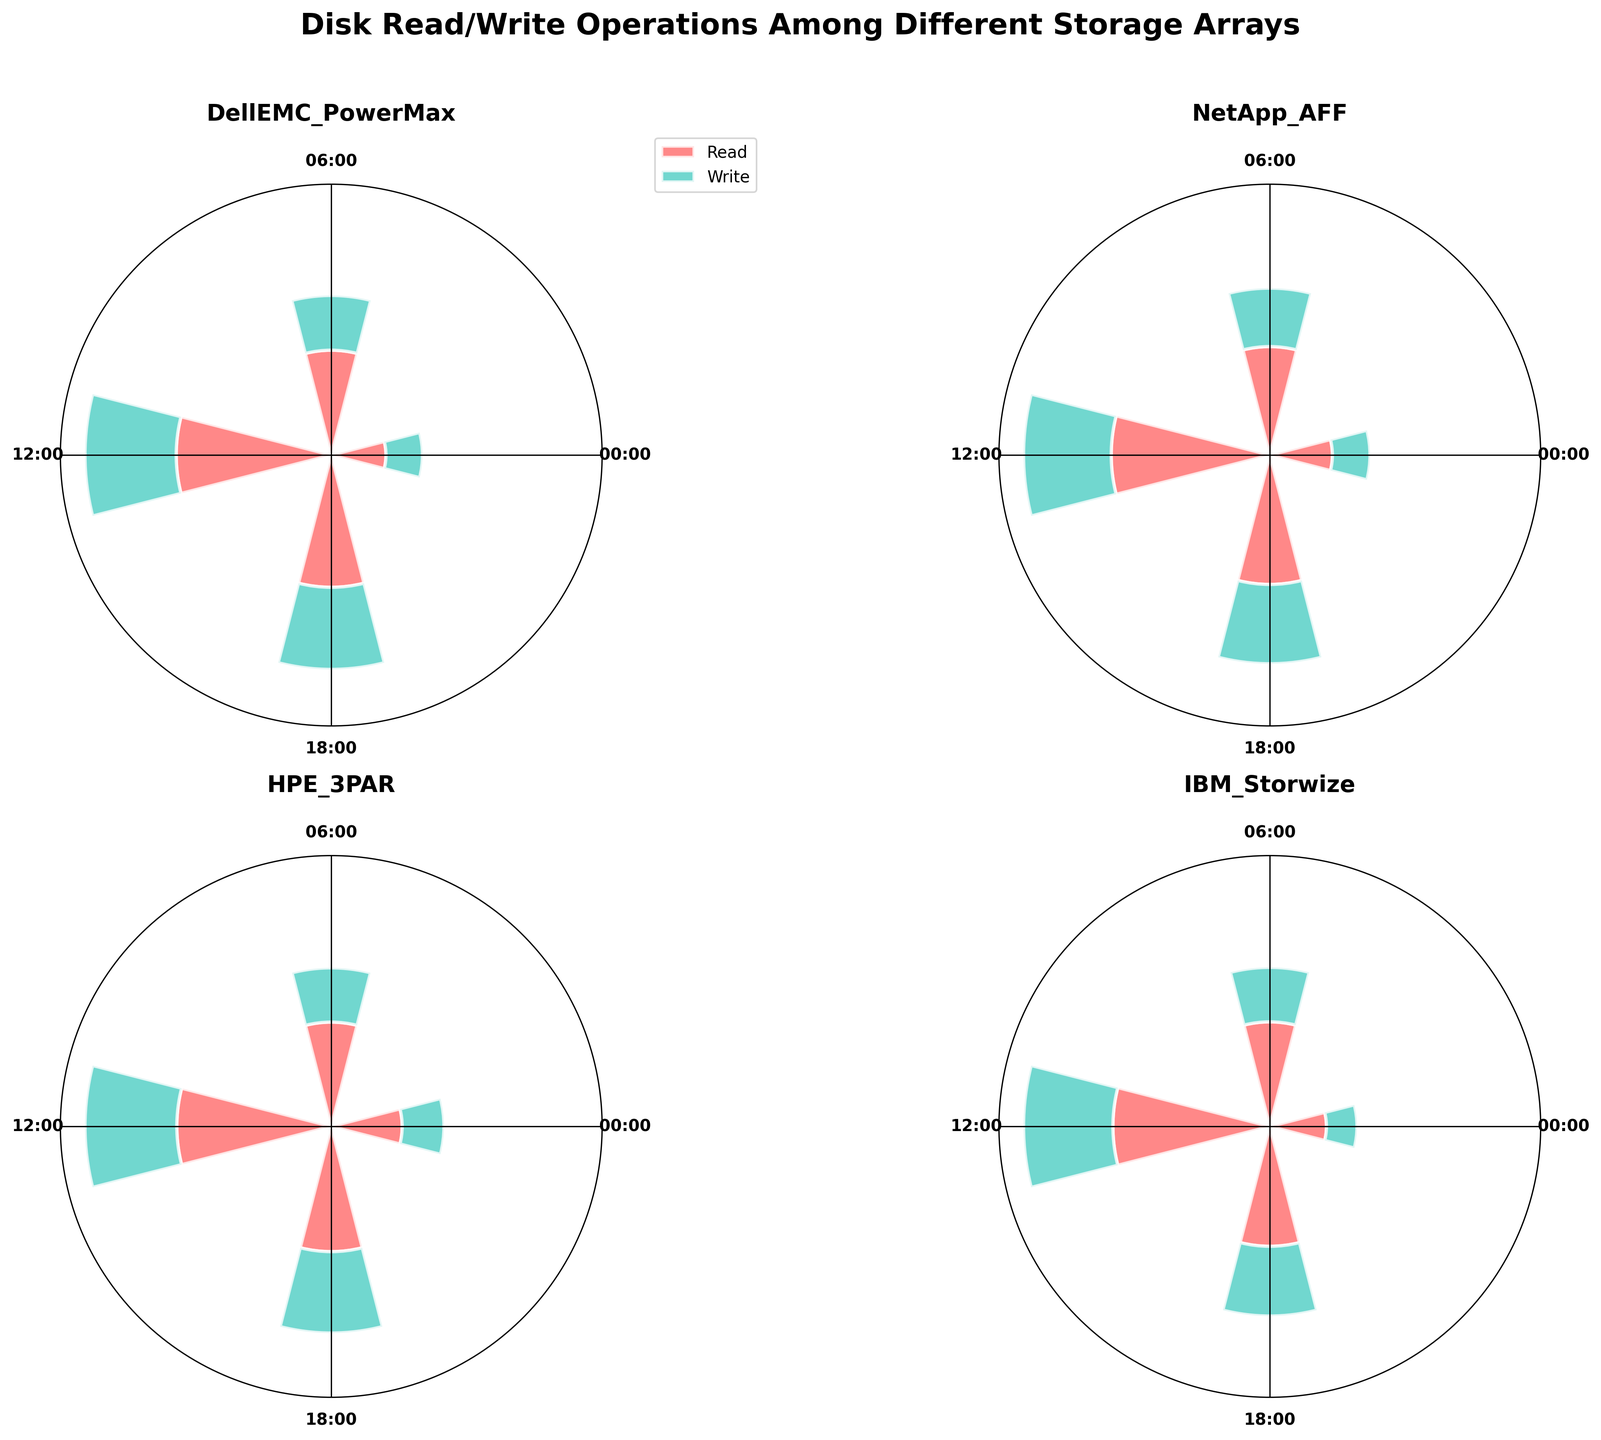What is the title of the figure? The title of the figure is in bold font at the top center, stating "Disk Read/Write Operations Among Different Storage Arrays".
Answer: Disk Read/Write Operations Among Different Storage Arrays What is the maximum number of operations recorded for reads at 12:00? By looking at the 12:00 mark around the polar plot for each storage array and identifying the highest bar labeled 'Read', the maximum number of operations is on the NetApp_AFF plot.
Answer: 380 How do DellEMC_PowerMax's read operations compare to write operations at 06:00? On DellEMC_PowerMax subplot, observe the two bars at the 06:00 label. The height of the read bar is greater than the write bar. Specifically, read operations are 230, while write operations are 120, showing read operations are higher.
Answer: Read operations are higher Which storage array has the least amount of write operations at 00:00? Looking at the 00:00 time on each subplot, and comparing the write operation bars (light green color), IBM_Storwize has the smallest bar.
Answer: IBM_Storwize On the polar plot for HPE_3PAR, at what time is the combined operations (read and write) highest? In the HPE_3PAR subplot, sum the read and write operations for each time mark. The combined operations bar at 12:00 is the highest.
Answer: 12:00 How does the number of read operations at 18:00 for NetApp_AFF compare to HPE_3PAR? Compare the read bars at 18:00 on the NetApp_AFF and HPE_3PAR subplots. NetApp_AFF has a read operation count of 310, whereas HPE_3PAR has 300, showing NetApp_AFF is higher.
Answer: NetApp_AFF is higher What are the colors used to represent read and write operations in the plot? Looking at the legend in the DellEMC_PowerMax subplot, read operations are represented by red bars, and write operations by green bars.
Answer: Red for read, Green for write Which storage array shows the most significant increase in read operations from 00:00 to 12:00? Calculate the difference between read operations at 12:00 and 00:00 for each storage array. NetApp_AFF shows the most significant increase with a difference of 380 - 150 = 230.
Answer: NetApp_AFF What is the total number of operations (read + write) for IBM_Storwize at 06:00? Sum the read and write operation counts at 06:00 on the IBM_Storwize subplot. The read is 240 and the write is 125. Total operations = 240 + 125 = 365.
Answer: 365 